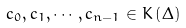Convert formula to latex. <formula><loc_0><loc_0><loc_500><loc_500>c _ { 0 } , c _ { 1 } , \cdots , c _ { n - 1 } \in K \left ( \Delta \right )</formula> 